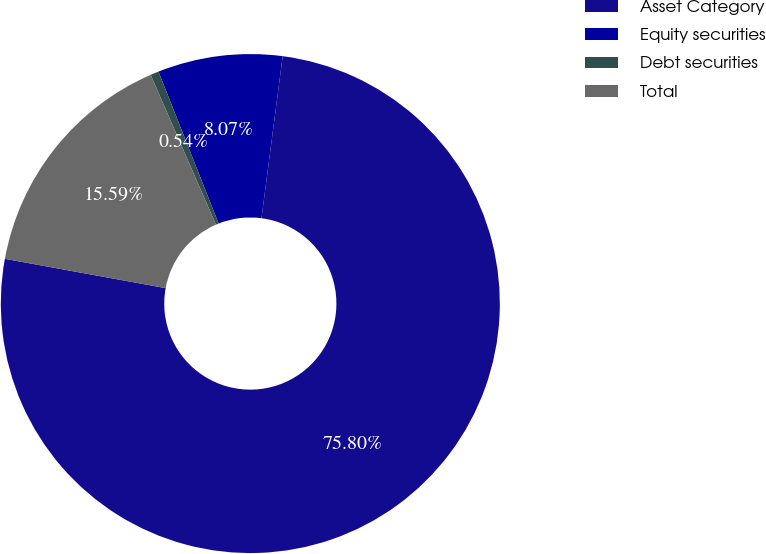Convert chart. <chart><loc_0><loc_0><loc_500><loc_500><pie_chart><fcel>Asset Category<fcel>Equity securities<fcel>Debt securities<fcel>Total<nl><fcel>75.8%<fcel>8.07%<fcel>0.54%<fcel>15.59%<nl></chart> 